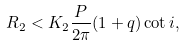Convert formula to latex. <formula><loc_0><loc_0><loc_500><loc_500>R _ { 2 } < K _ { 2 } \frac { P } { 2 \pi } ( 1 + q ) \cot i ,</formula> 